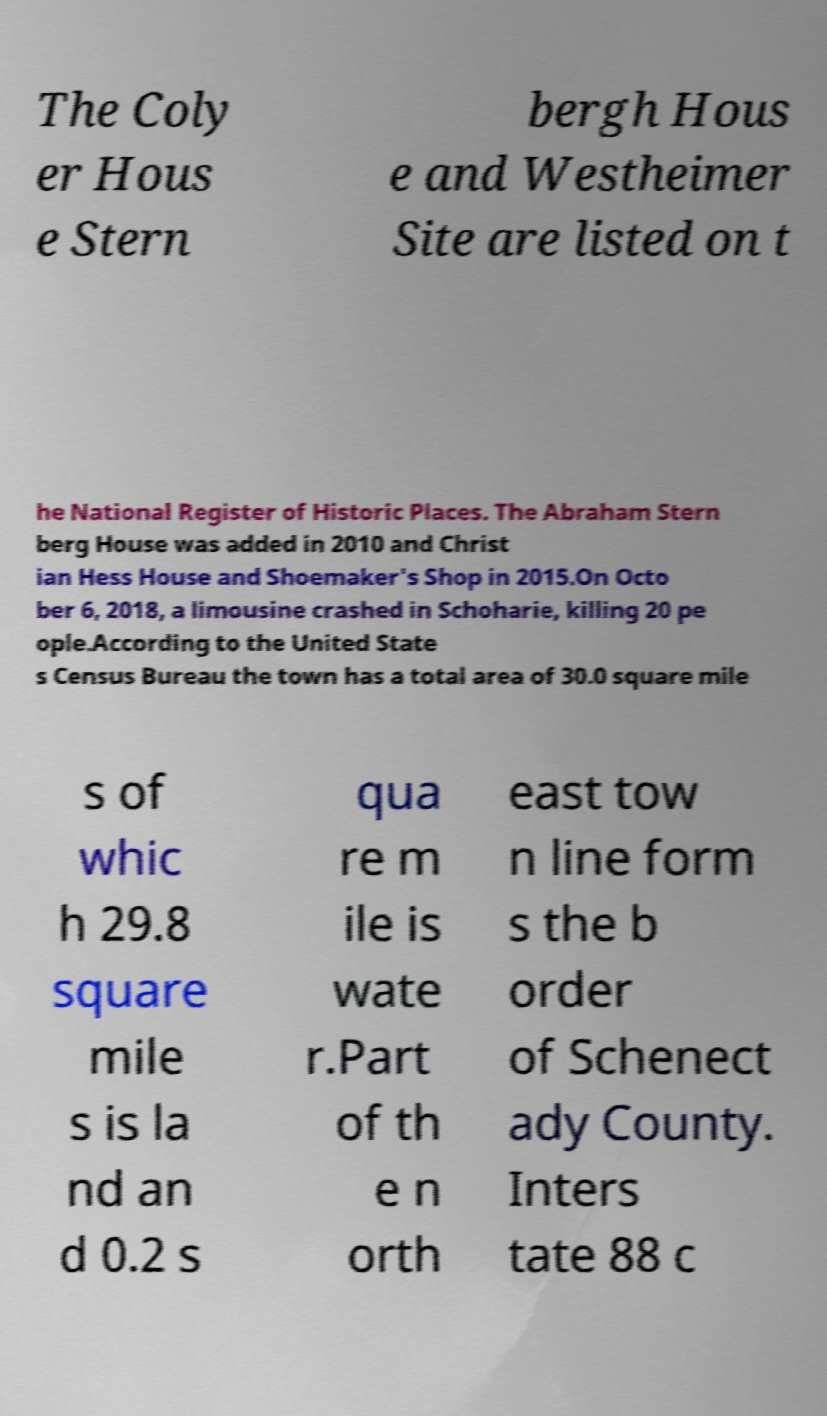I need the written content from this picture converted into text. Can you do that? The Coly er Hous e Stern bergh Hous e and Westheimer Site are listed on t he National Register of Historic Places. The Abraham Stern berg House was added in 2010 and Christ ian Hess House and Shoemaker's Shop in 2015.On Octo ber 6, 2018, a limousine crashed in Schoharie, killing 20 pe ople.According to the United State s Census Bureau the town has a total area of 30.0 square mile s of whic h 29.8 square mile s is la nd an d 0.2 s qua re m ile is wate r.Part of th e n orth east tow n line form s the b order of Schenect ady County. Inters tate 88 c 